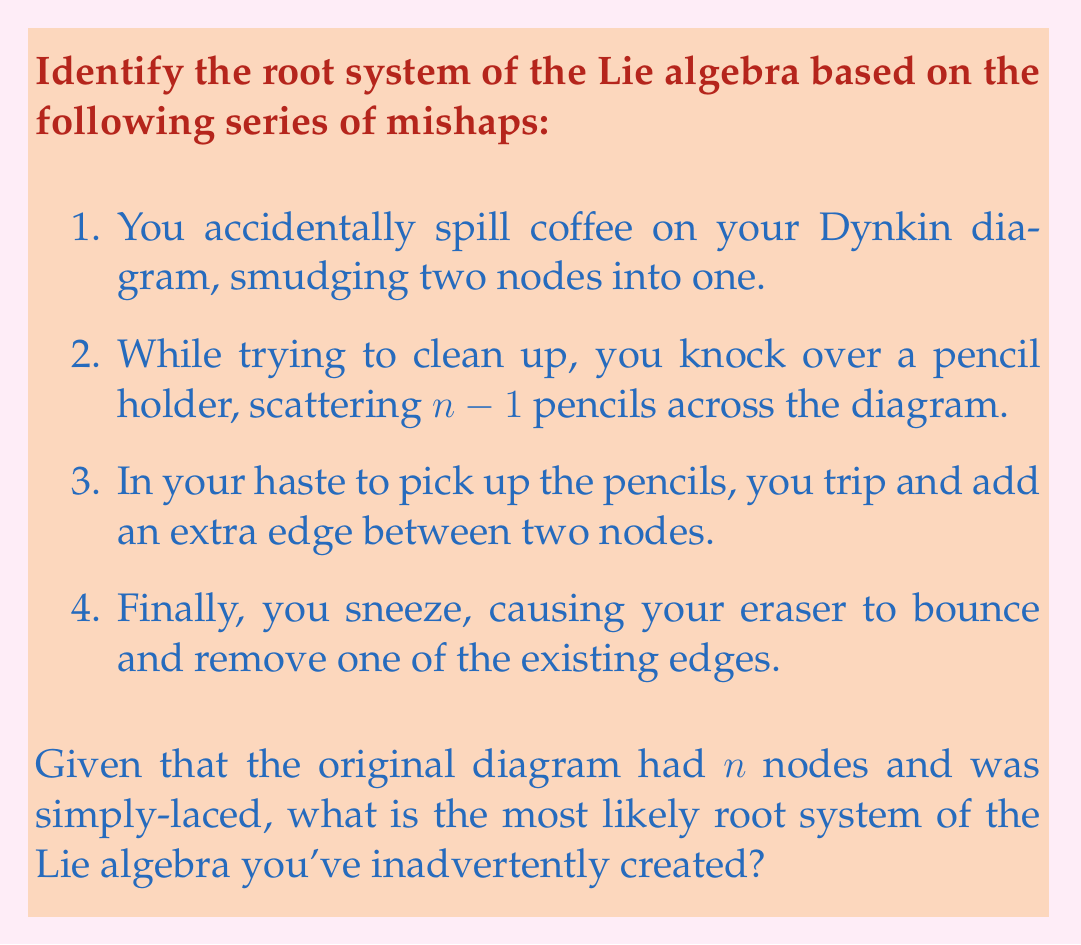Give your solution to this math problem. Let's analyze each mishap and its effect on the Dynkin diagram:

1. Smudging two nodes into one: This reduces the number of nodes from $n$ to $n-1$.

2. Scattering $n-1$ pencils: This doesn't affect the diagram, but hints that we now have $n-1$ nodes.

3. Adding an extra edge: This creates a multiple edge between two nodes.

4. Removing one existing edge: This simplifies one connection in the diagram.

Given these changes, we can deduce:

- We started with a simply-laced Dynkin diagram with $n$ nodes.
- We ended up with a diagram that has $n-1$ nodes and one multiple edge.

The most likely root system that matches this description is $C_{n-1}$. Here's why:

- $C_{n-1}$ has $n-1$ nodes.
- It has a double edge between the last two nodes.
- All other connections are single edges.

The $C_{n-1}$ Dynkin diagram looks like this:

$$
\circ-\circ-\circ-\cdots-\circ\Rightarrow\circ
$$

This matches our scenario where we reduced the number of nodes by one and introduced a multiple edge.
Answer: The most likely root system of the Lie algebra inadvertently created is $C_{n-1}$. 